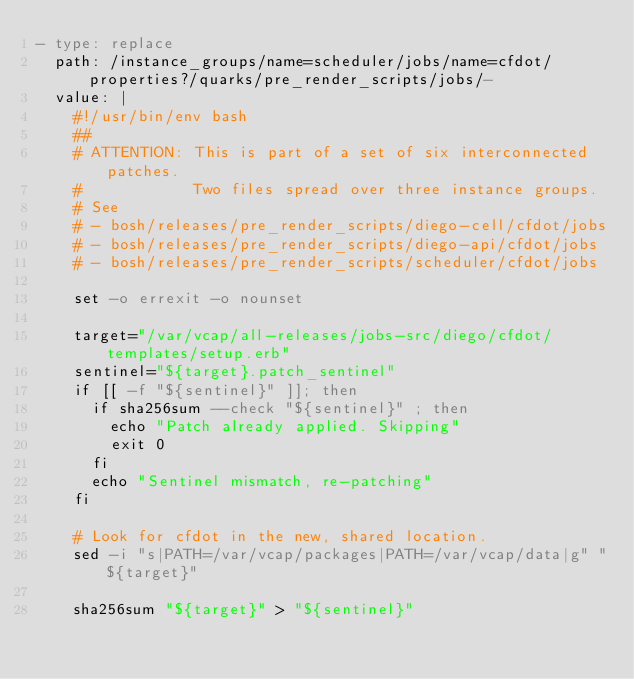Convert code to text. <code><loc_0><loc_0><loc_500><loc_500><_YAML_>- type: replace
  path: /instance_groups/name=scheduler/jobs/name=cfdot/properties?/quarks/pre_render_scripts/jobs/-
  value: |
    #!/usr/bin/env bash
    ##
    # ATTENTION: This is part of a set of six interconnected patches.
    #            Two files spread over three instance groups.
    # See
    # - bosh/releases/pre_render_scripts/diego-cell/cfdot/jobs
    # - bosh/releases/pre_render_scripts/diego-api/cfdot/jobs
    # - bosh/releases/pre_render_scripts/scheduler/cfdot/jobs
    
    set -o errexit -o nounset
    
    target="/var/vcap/all-releases/jobs-src/diego/cfdot/templates/setup.erb"
    sentinel="${target}.patch_sentinel"
    if [[ -f "${sentinel}" ]]; then
      if sha256sum --check "${sentinel}" ; then
        echo "Patch already applied. Skipping"
        exit 0
      fi
      echo "Sentinel mismatch, re-patching"
    fi
    
    # Look for cfdot in the new, shared location.
    sed -i "s|PATH=/var/vcap/packages|PATH=/var/vcap/data|g" "${target}"
    
    sha256sum "${target}" > "${sentinel}"
</code> 